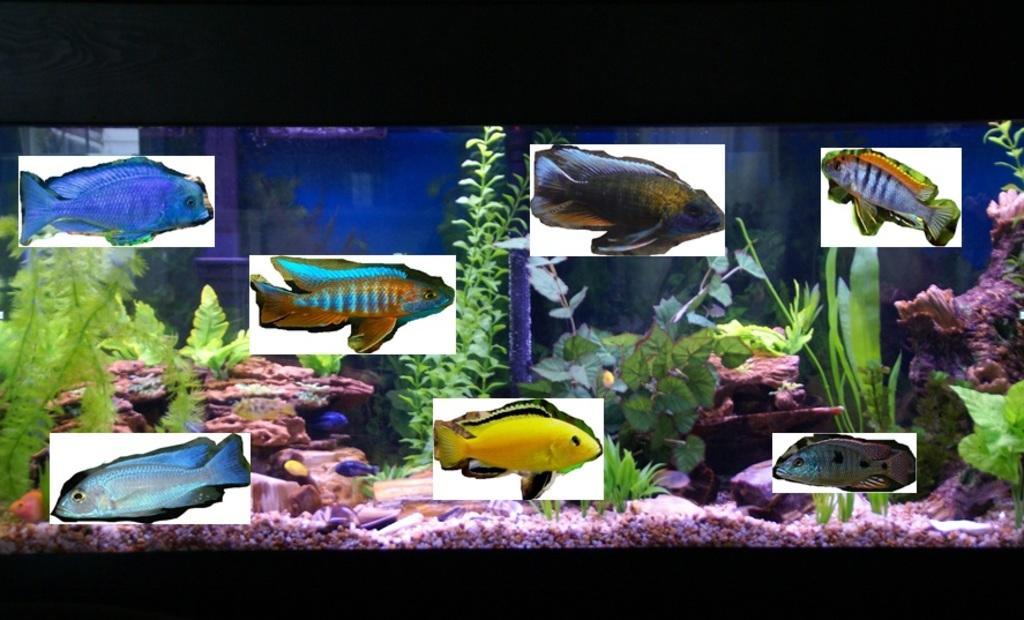Please provide a concise description of this image. In this image we can see fishes, in the aquarium, here are small plants, here are the stones, here is the water in blue color. 